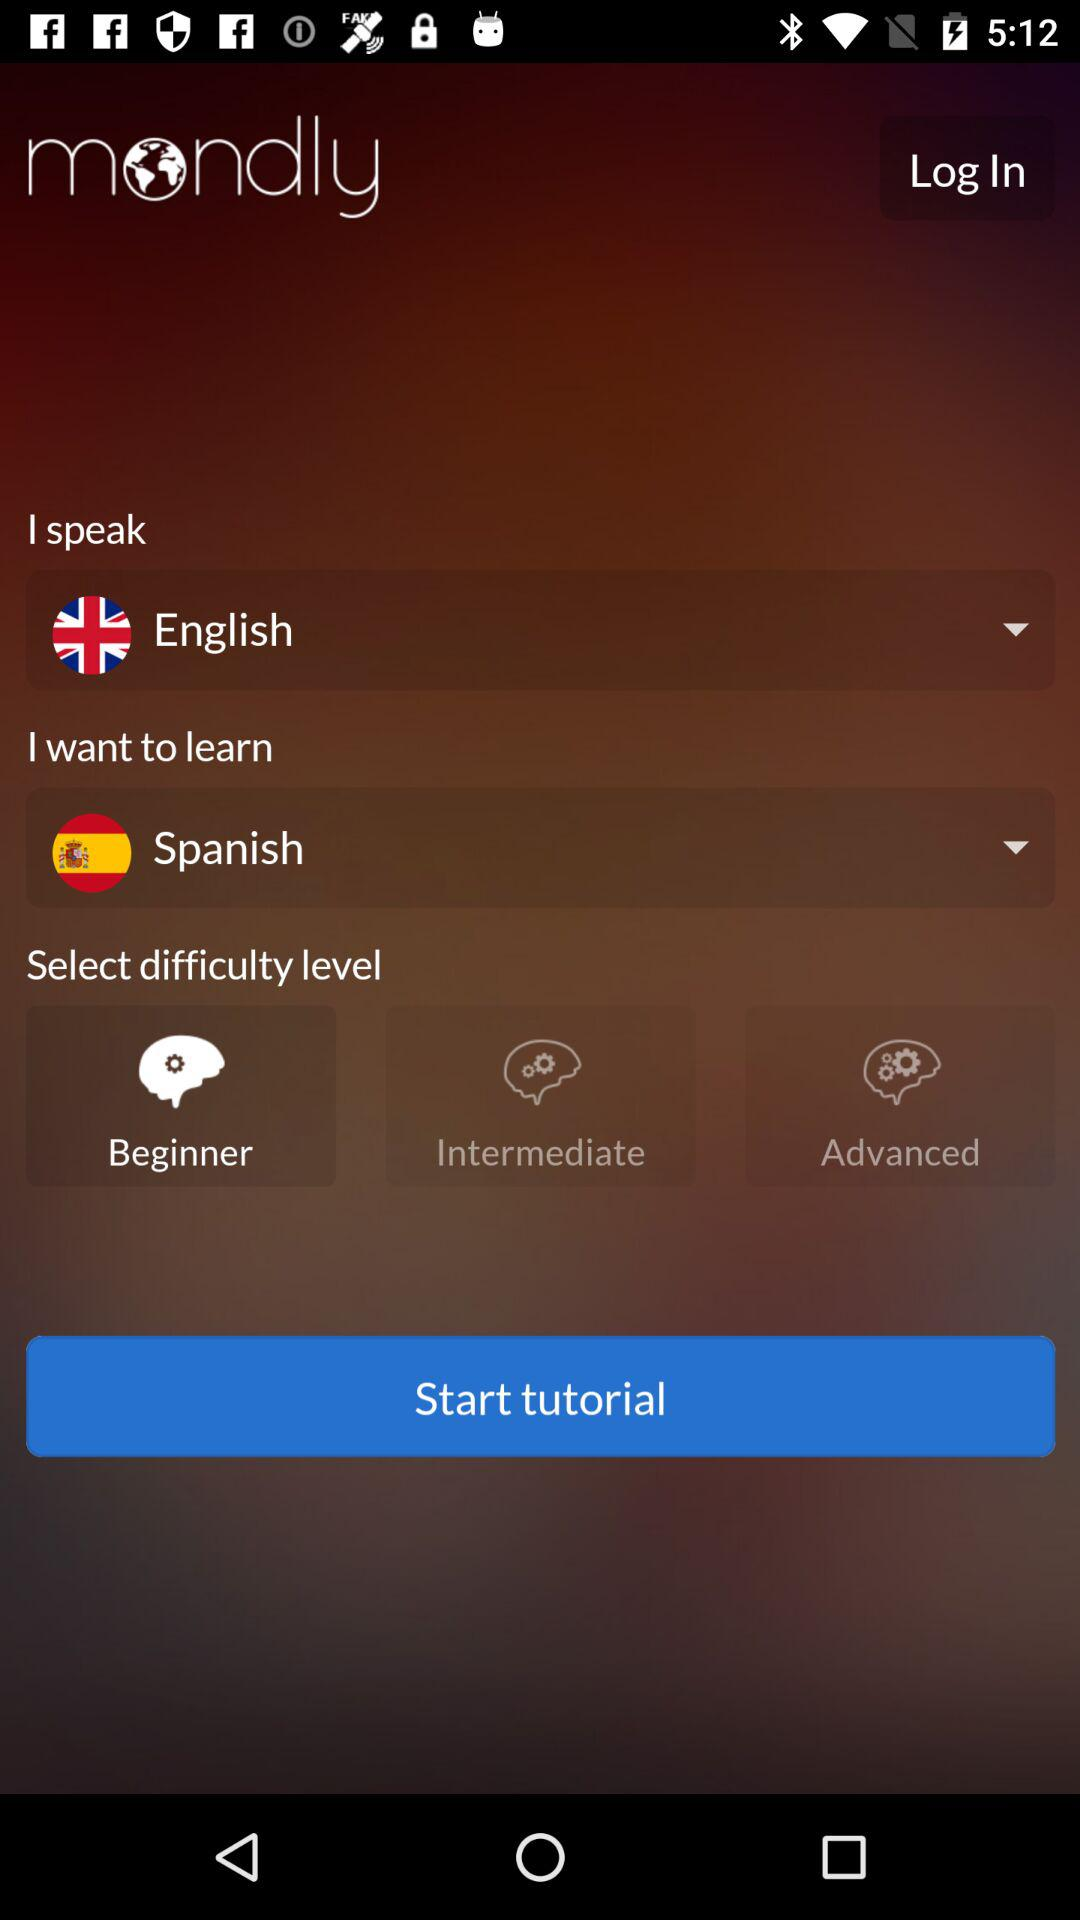How many difficulty levels are available?
Answer the question using a single word or phrase. 3 